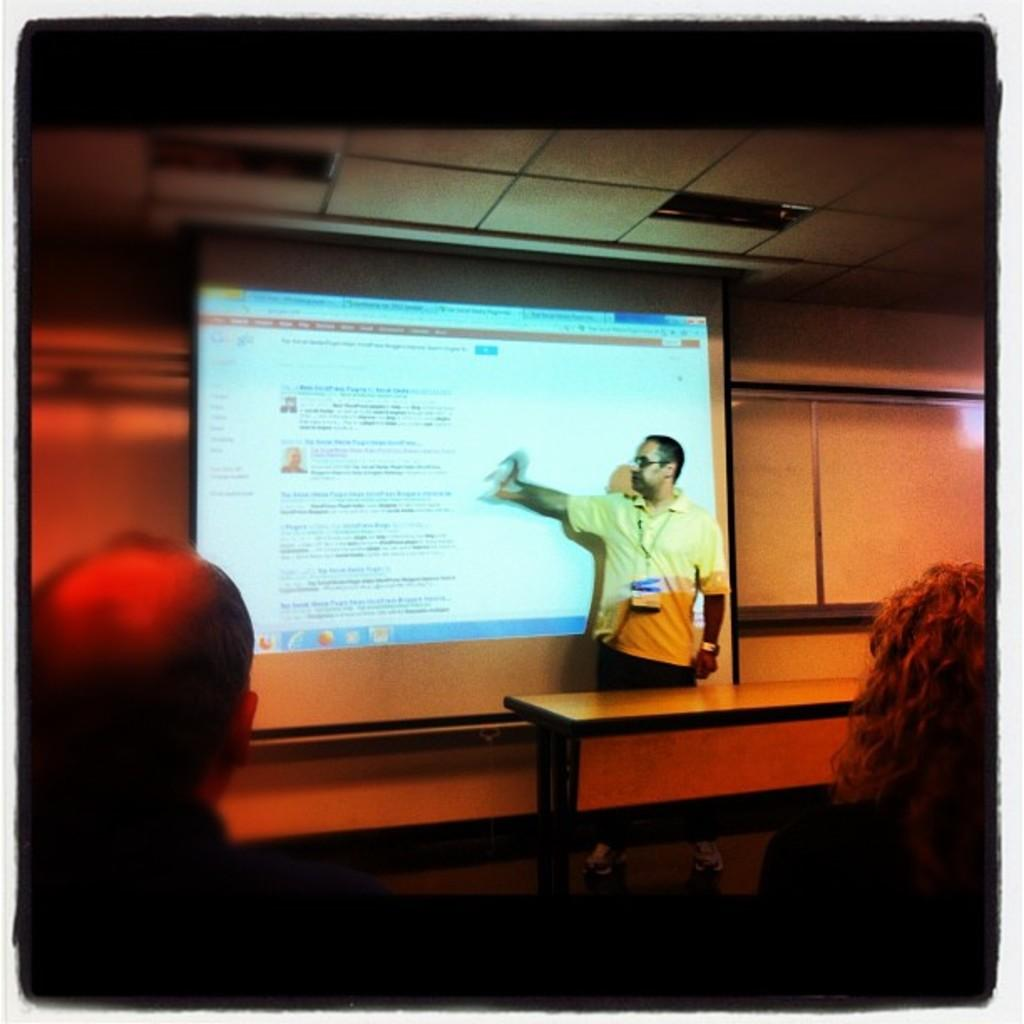What is the main subject of the image? There is a man standing in the center of the image. What is the man doing in the image? The man is explaining something. What can be seen in the background of the image? There is a screen and a table in the background of the image. Who else is present in the image? There are people sitting at the bottom of the image. What type of lunch is being served to the girls in the image? There are no girls or lunch present in the image. What are the people learning about in the image? The image does not specify what the man is explaining or what the people are learning about. 